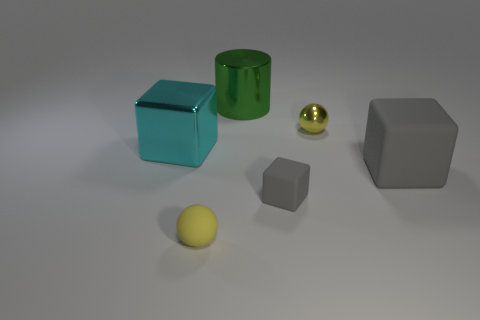Add 3 big purple blocks. How many objects exist? 9 Subtract all cylinders. How many objects are left? 5 Add 4 gray matte blocks. How many gray matte blocks are left? 6 Add 6 yellow rubber spheres. How many yellow rubber spheres exist? 7 Subtract 0 yellow cylinders. How many objects are left? 6 Subtract all small purple metallic things. Subtract all tiny gray things. How many objects are left? 5 